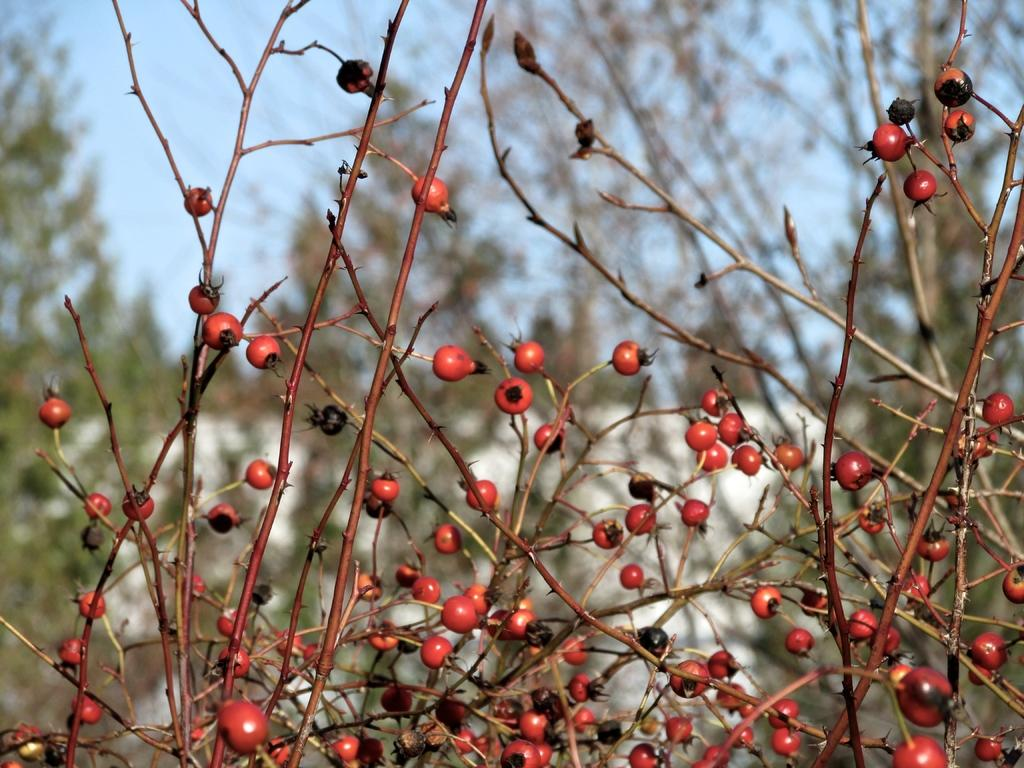What type of plants are visible in the image? There are plants with fruits in the image. Can you describe the background of the image? The background of the image is blurry. What type of zephyr is playing the record on the route in the image? There is no zephyr, record, or route present in the image. 